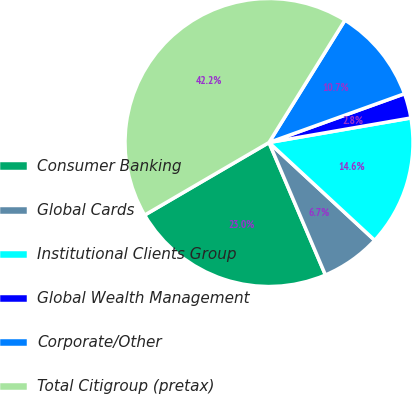Convert chart to OTSL. <chart><loc_0><loc_0><loc_500><loc_500><pie_chart><fcel>Consumer Banking<fcel>Global Cards<fcel>Institutional Clients Group<fcel>Global Wealth Management<fcel>Corporate/Other<fcel>Total Citigroup (pretax)<nl><fcel>23.0%<fcel>6.71%<fcel>14.61%<fcel>2.77%<fcel>10.66%<fcel>42.25%<nl></chart> 